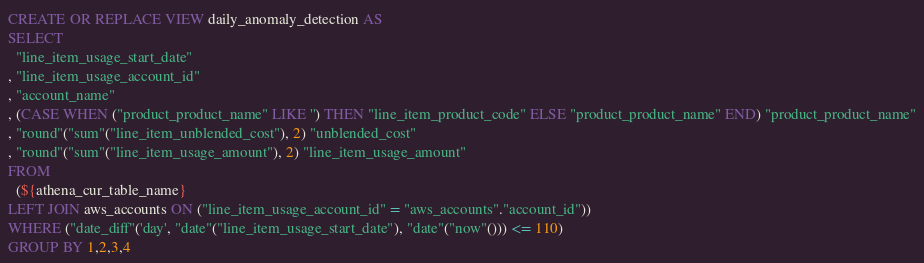<code> <loc_0><loc_0><loc_500><loc_500><_SQL_>CREATE OR REPLACE VIEW daily_anomaly_detection AS
SELECT
  "line_item_usage_start_date"
, "line_item_usage_account_id"
, "account_name"
, (CASE WHEN ("product_product_name" LIKE '') THEN "line_item_product_code" ELSE "product_product_name" END) "product_product_name"
, "round"("sum"("line_item_unblended_cost"), 2) "unblended_cost"
, "round"("sum"("line_item_usage_amount"), 2) "line_item_usage_amount"
FROM
  (${athena_cur_table_name}
LEFT JOIN aws_accounts ON ("line_item_usage_account_id" = "aws_accounts"."account_id"))
WHERE ("date_diff"('day', "date"("line_item_usage_start_date"), "date"("now"())) <= 110)
GROUP BY 1,2,3,4
</code> 